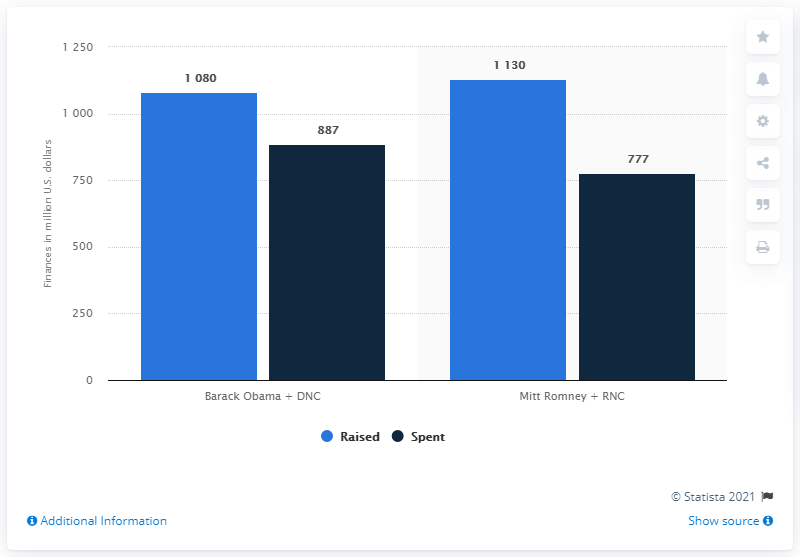Draw attention to some important aspects in this diagram. During the 2012 presidential election, the Barack Obama campaign and the Democratic National Committee raised a total of $1080 million in funds. The total amount of blue bars is 2210. 